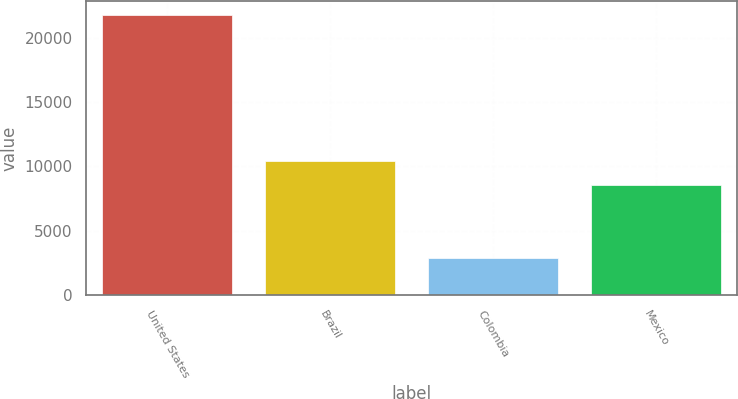Convert chart. <chart><loc_0><loc_0><loc_500><loc_500><bar_chart><fcel>United States<fcel>Brazil<fcel>Colombia<fcel>Mexico<nl><fcel>21722<fcel>10434.8<fcel>2884<fcel>8551<nl></chart> 